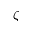<formula> <loc_0><loc_0><loc_500><loc_500>\zeta</formula> 